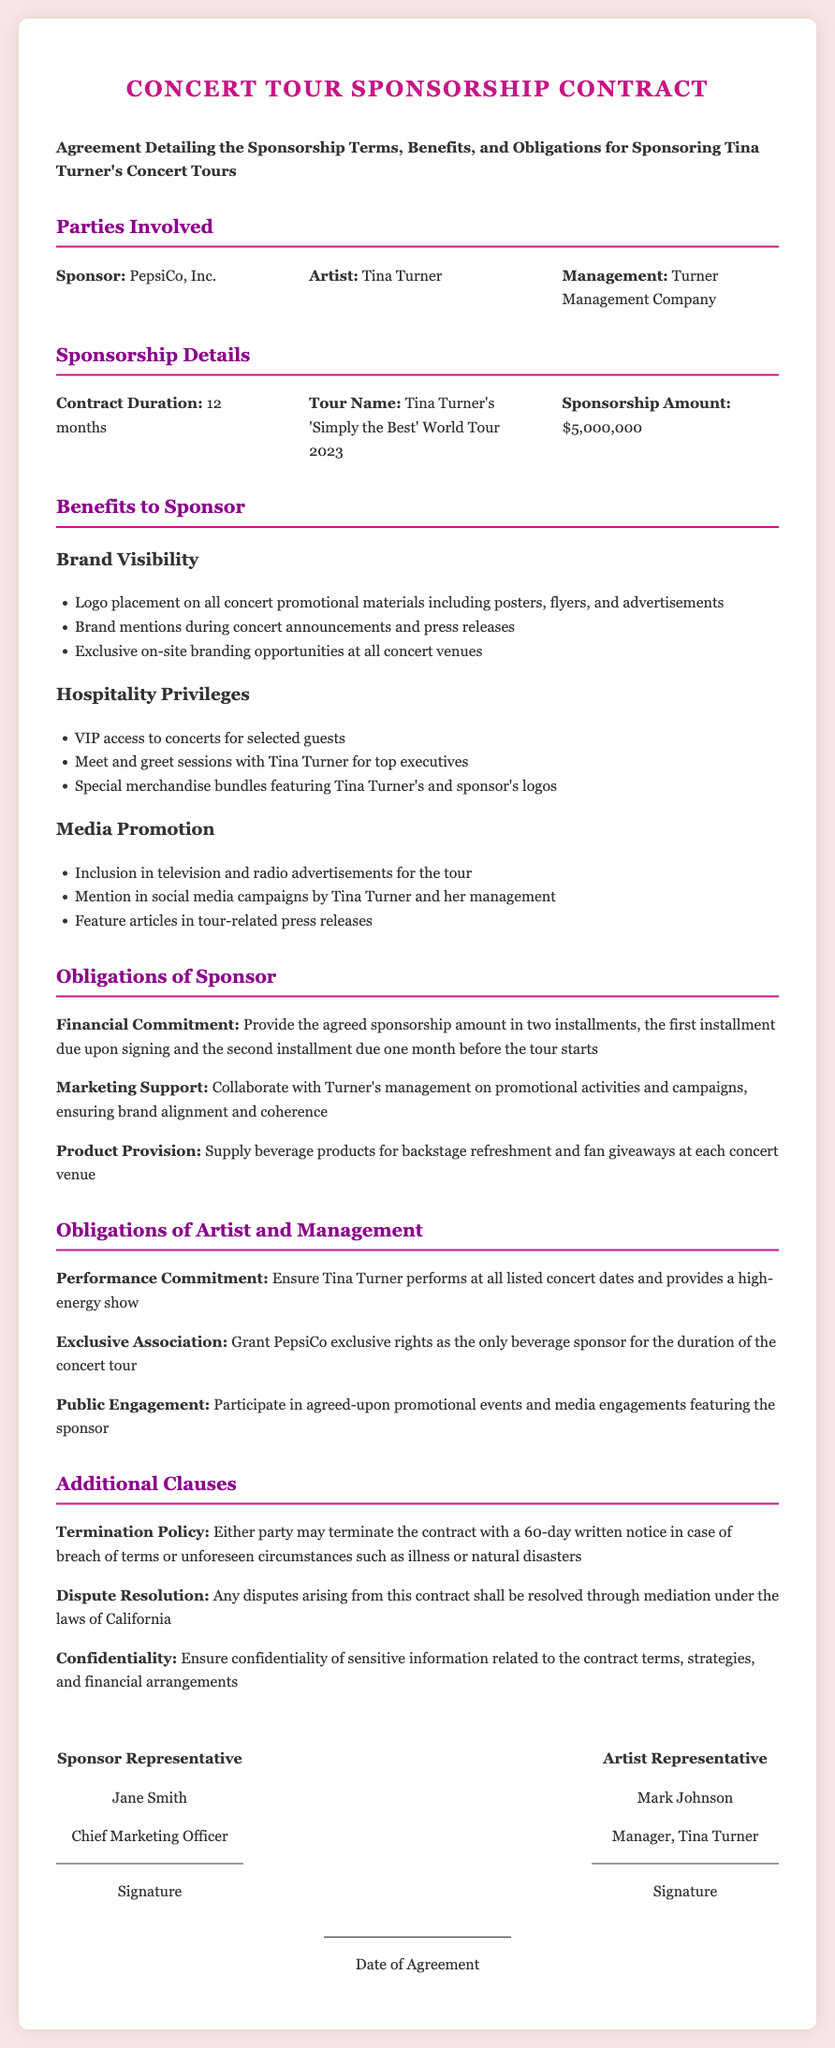what is the name of the tour? The name of the tour is specifically mentioned in the details section of the contract.
Answer: 'Simply the Best' World Tour 2023 who is the sponsor of the concert tour? The sponsor is listed at the beginning of the document under the parties involved section.
Answer: PepsiCo, Inc how much is the sponsorship amount? The sponsorship amount is detailed in the sponsorship details section of the contract.
Answer: $5,000,000 what is the duration of the contract? The duration is specified in the sponsorship details section, outlining how long the agreement will last.
Answer: 12 months what obligations does the sponsor have regarding product provision? The obligations of the sponsor include specific duties that are laid out in the obligations section.
Answer: Supply beverage products for backstage refreshment and fan giveaways at each concert venue what is the termination policy for this contract? The termination policy outlines the process for ending the contract and is found in the additional clauses section.
Answer: 60-day written notice how often will Tina Turner perform during the tour? Tina Turner's performance commitments specify her engagement throughout the tour, indicating consistency.
Answer: At all listed concert dates who will have exclusive rights as a beverage sponsor? This detail is embedded in the obligations of the artist section and addresses the exclusivity of the sponsorship.
Answer: PepsiCo what will the sponsor receive in terms of brand visibility? The benefits regarding brand visibility are listed under the benefits to sponsor section.
Answer: Logo placement on all concert promotional materials what is required for dispute resolution as per the contract? The document specifies how to handle disputes, which is unique to contracts and is found under additional clauses.
Answer: Mediation under the laws of California 